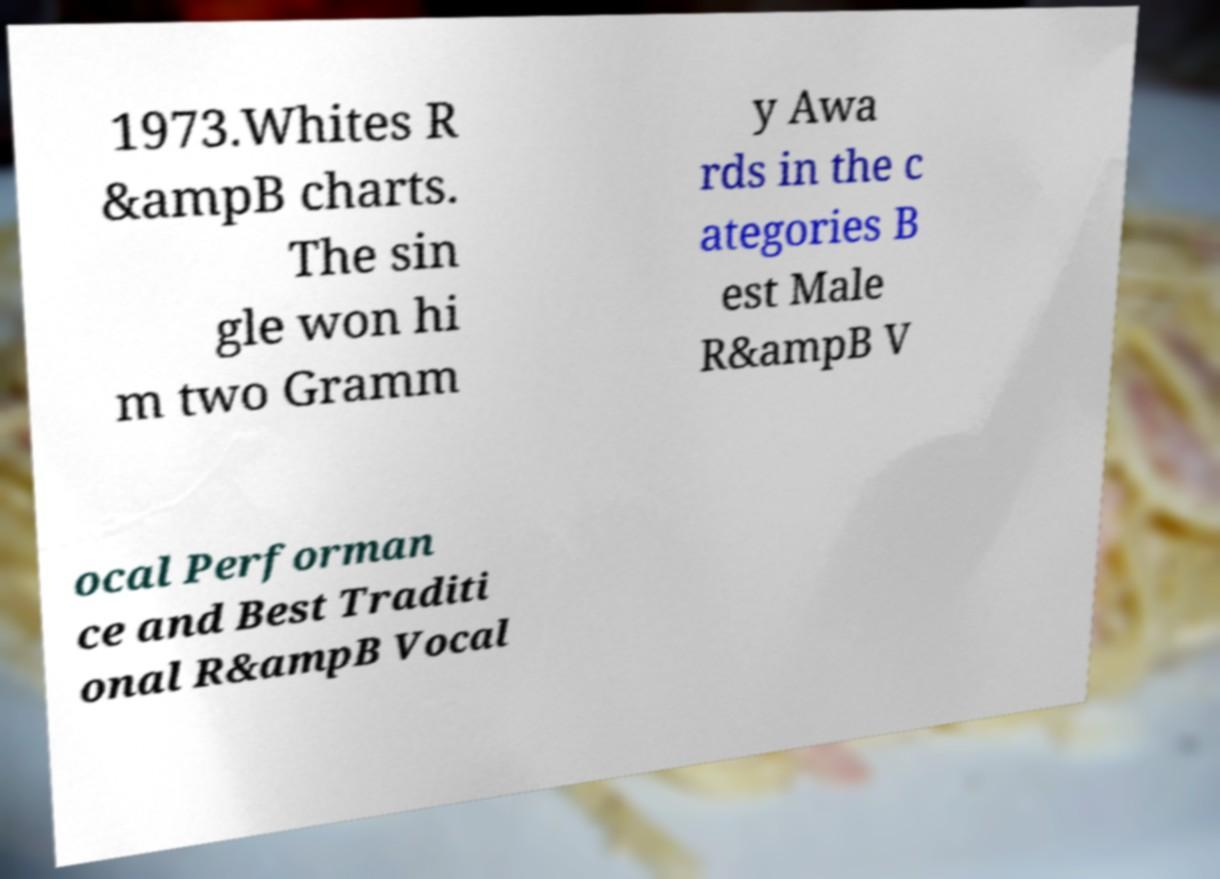Could you extract and type out the text from this image? 1973.Whites R &ampB charts. The sin gle won hi m two Gramm y Awa rds in the c ategories B est Male R&ampB V ocal Performan ce and Best Traditi onal R&ampB Vocal 